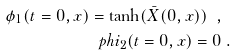Convert formula to latex. <formula><loc_0><loc_0><loc_500><loc_500>\phi _ { 1 } ( t = 0 , x ) = \tanh ( { \bar { X } } ( 0 , x ) ) \ , \ \\ p h i _ { 2 } ( t = 0 , x ) = 0 \ .</formula> 